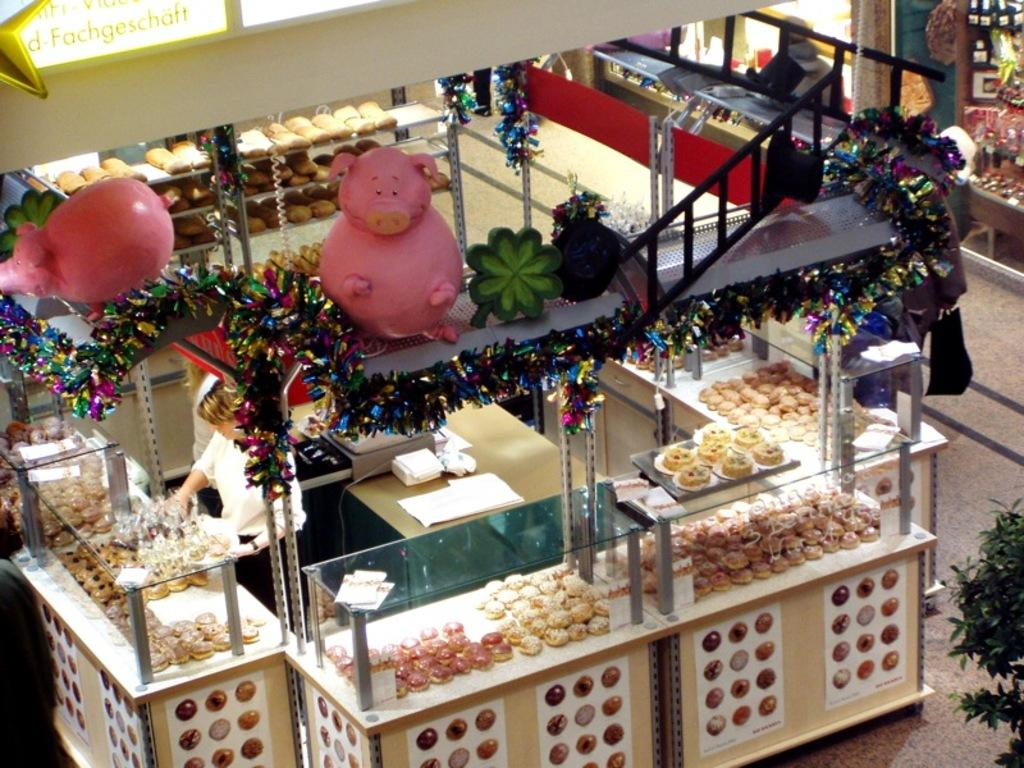What objects can be seen in the image? There are boxes, decorative items, dishes, and a plant on the right side of the image. How many persons are present in the image? There are two persons wearing white color dresses in the image. What type of items might be used for storage or organization? The boxes in the image might be used for storage or organization. What can be seen on the right side of the image? There is a plant on the right side of the image. What song is being sung by the ladybug in the image? There is no ladybug present in the image, and therefore no such activity can be observed. 